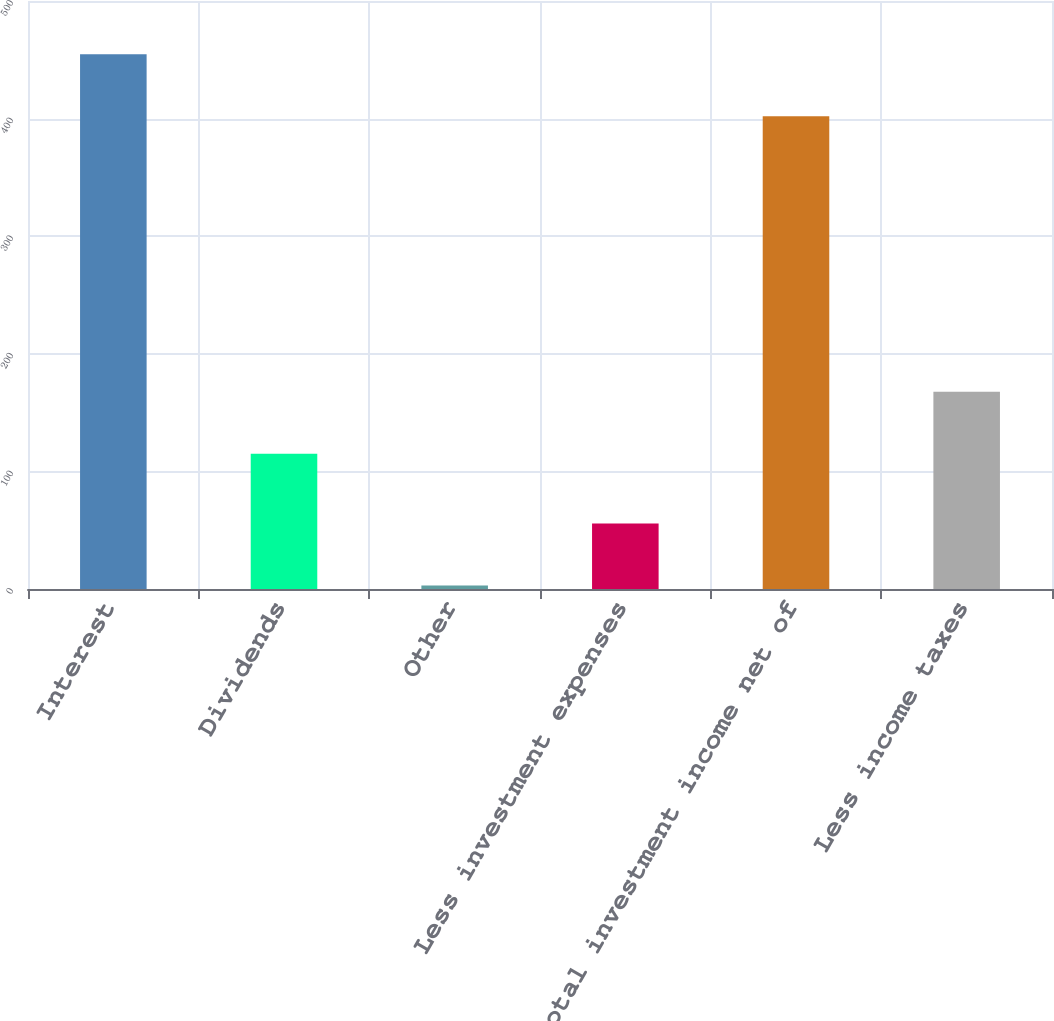<chart> <loc_0><loc_0><loc_500><loc_500><bar_chart><fcel>Interest<fcel>Dividends<fcel>Other<fcel>Less investment expenses<fcel>Total investment income net of<fcel>Less income taxes<nl><fcel>454.8<fcel>115<fcel>3<fcel>55.8<fcel>402<fcel>167.8<nl></chart> 